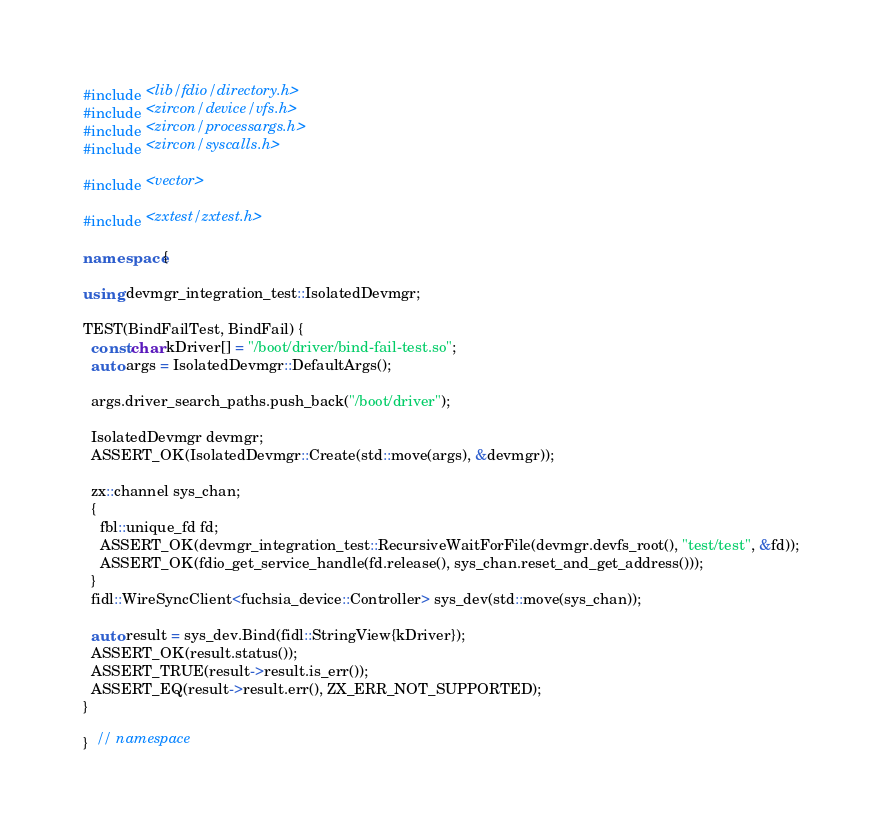<code> <loc_0><loc_0><loc_500><loc_500><_C++_>#include <lib/fdio/directory.h>
#include <zircon/device/vfs.h>
#include <zircon/processargs.h>
#include <zircon/syscalls.h>

#include <vector>

#include <zxtest/zxtest.h>

namespace {

using devmgr_integration_test::IsolatedDevmgr;

TEST(BindFailTest, BindFail) {
  const char kDriver[] = "/boot/driver/bind-fail-test.so";
  auto args = IsolatedDevmgr::DefaultArgs();

  args.driver_search_paths.push_back("/boot/driver");

  IsolatedDevmgr devmgr;
  ASSERT_OK(IsolatedDevmgr::Create(std::move(args), &devmgr));

  zx::channel sys_chan;
  {
    fbl::unique_fd fd;
    ASSERT_OK(devmgr_integration_test::RecursiveWaitForFile(devmgr.devfs_root(), "test/test", &fd));
    ASSERT_OK(fdio_get_service_handle(fd.release(), sys_chan.reset_and_get_address()));
  }
  fidl::WireSyncClient<fuchsia_device::Controller> sys_dev(std::move(sys_chan));

  auto result = sys_dev.Bind(fidl::StringView{kDriver});
  ASSERT_OK(result.status());
  ASSERT_TRUE(result->result.is_err());
  ASSERT_EQ(result->result.err(), ZX_ERR_NOT_SUPPORTED);
}

}  // namespace
</code> 